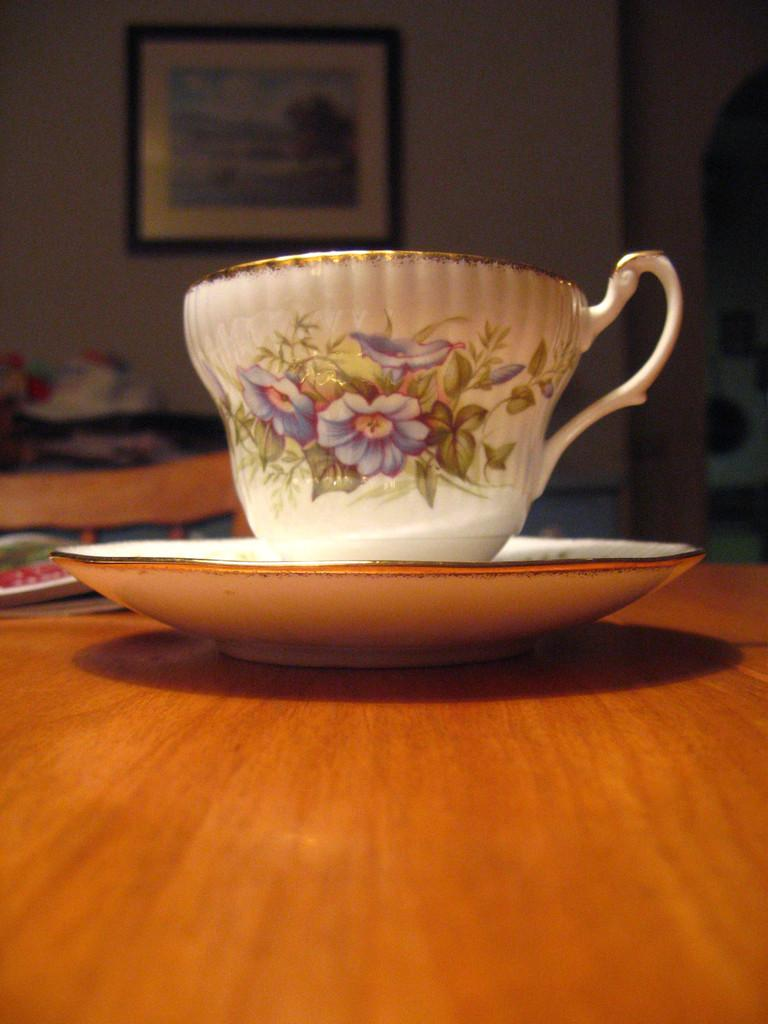What objects are present on the wooden surface in the image? There is a cup and saucer on the wooden surface in the image. What is the material of the surface where the cup and saucer are placed? The wooden surface is made of wood. Can you describe anything visible on the wall in the background of the image? There is a photo frame on the wall in the background of the image. What type of camera is being used to take the photo of the cup and saucer? There is no camera visible in the image, as it is a still photo of the cup and saucer on a wooden surface. What is the opinion of the flag in the image? There is no flag present in the image, so it is not possible to determine its opinion. 